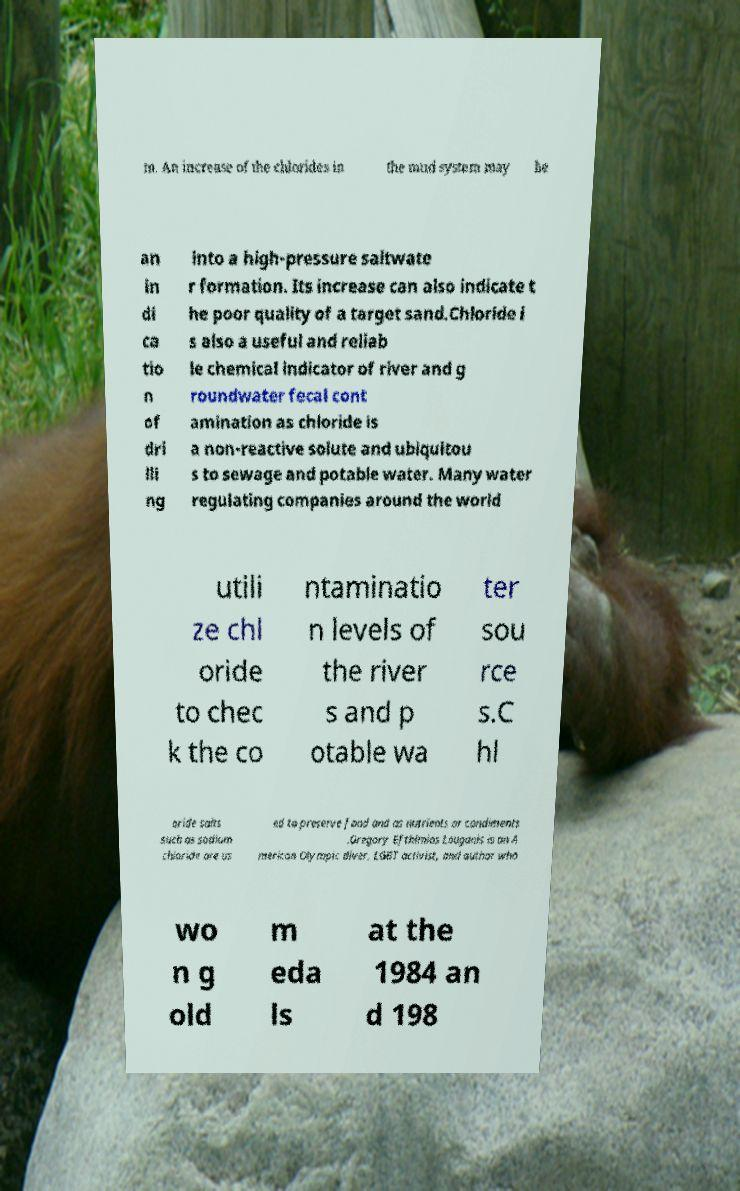Please read and relay the text visible in this image. What does it say? m. An increase of the chlorides in the mud system may be an in di ca tio n of dri lli ng into a high-pressure saltwate r formation. Its increase can also indicate t he poor quality of a target sand.Chloride i s also a useful and reliab le chemical indicator of river and g roundwater fecal cont amination as chloride is a non-reactive solute and ubiquitou s to sewage and potable water. Many water regulating companies around the world utili ze chl oride to chec k the co ntaminatio n levels of the river s and p otable wa ter sou rce s.C hl oride salts such as sodium chloride are us ed to preserve food and as nutrients or condiments .Gregory Efthimios Louganis is an A merican Olympic diver, LGBT activist, and author who wo n g old m eda ls at the 1984 an d 198 